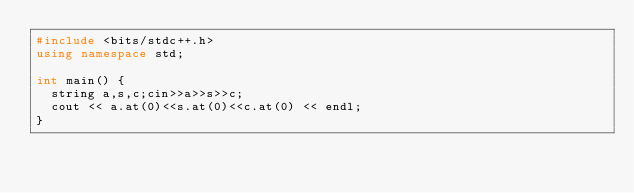<code> <loc_0><loc_0><loc_500><loc_500><_C++_>#include <bits/stdc++.h>
using namespace std;

int main() {
  string a,s,c;cin>>a>>s>>c;
  cout << a.at(0)<<s.at(0)<<c.at(0) << endl;
}
</code> 